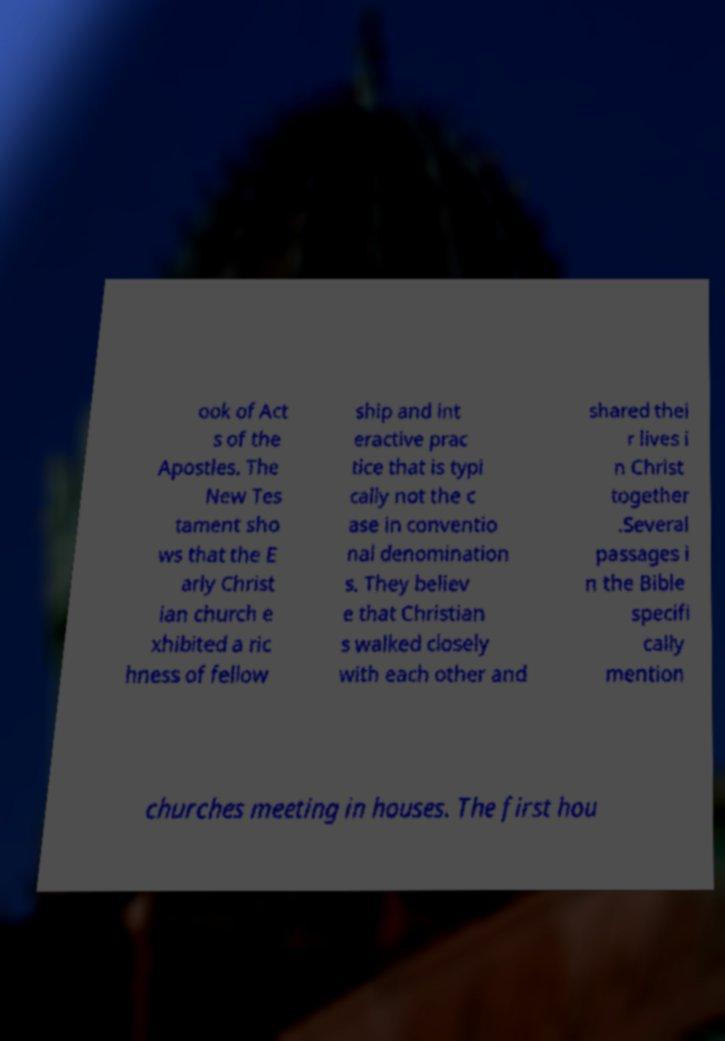Could you extract and type out the text from this image? ook of Act s of the Apostles. The New Tes tament sho ws that the E arly Christ ian church e xhibited a ric hness of fellow ship and int eractive prac tice that is typi cally not the c ase in conventio nal denomination s. They believ e that Christian s walked closely with each other and shared thei r lives i n Christ together .Several passages i n the Bible specifi cally mention churches meeting in houses. The first hou 